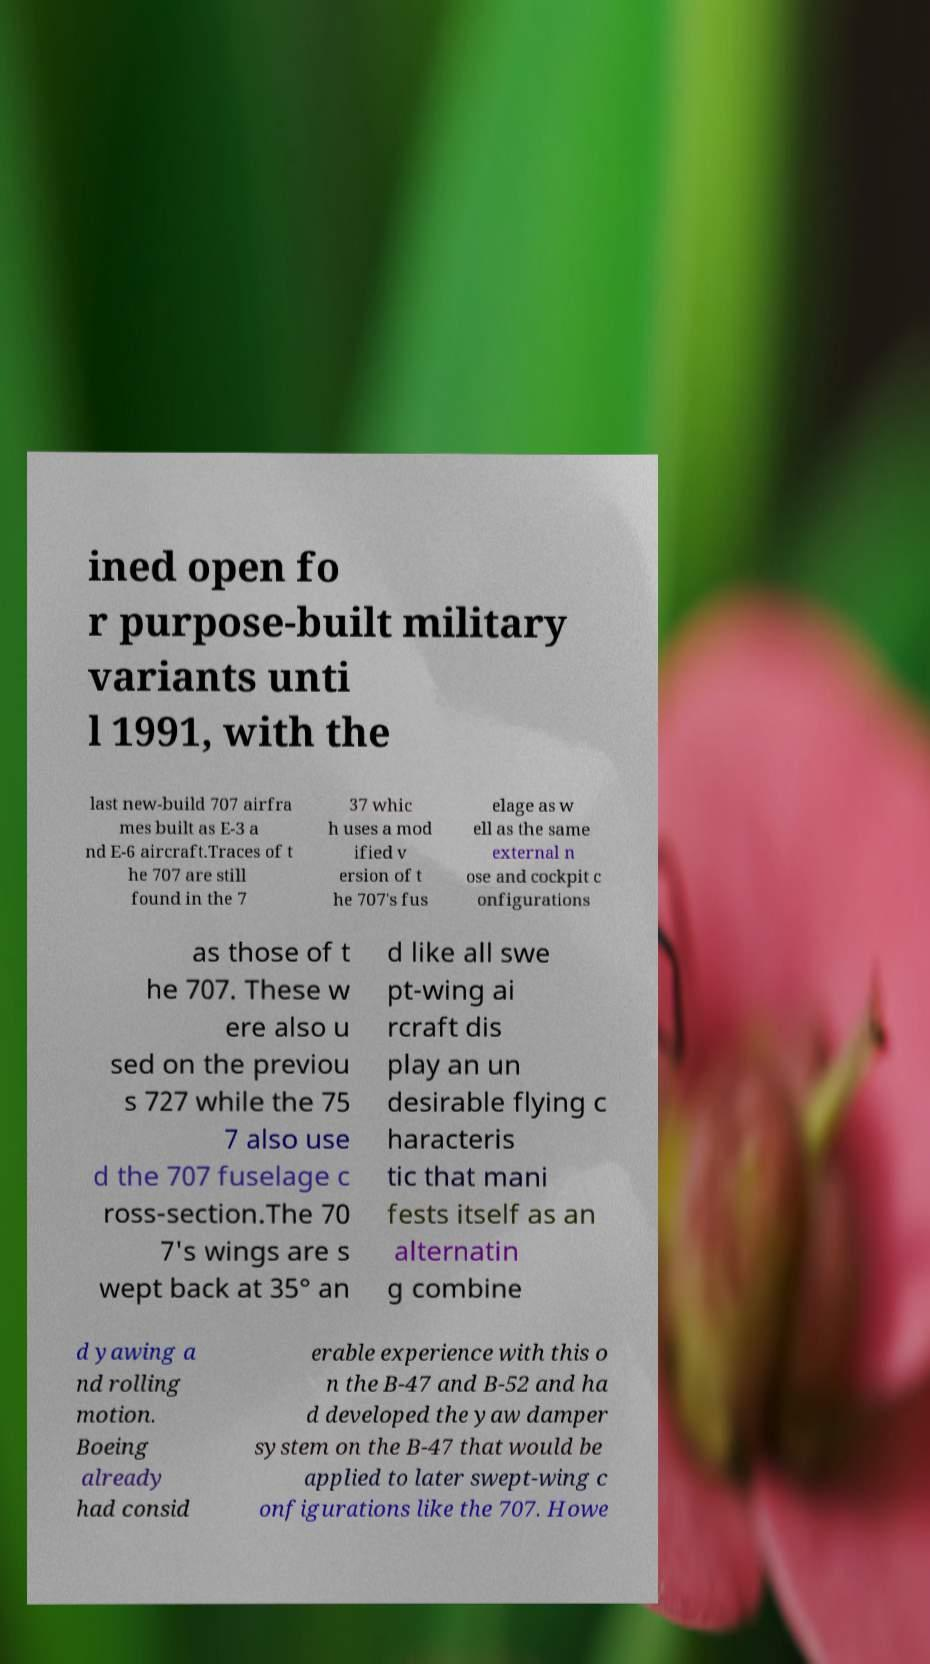Please read and relay the text visible in this image. What does it say? ined open fo r purpose-built military variants unti l 1991, with the last new-build 707 airfra mes built as E-3 a nd E-6 aircraft.Traces of t he 707 are still found in the 7 37 whic h uses a mod ified v ersion of t he 707's fus elage as w ell as the same external n ose and cockpit c onfigurations as those of t he 707. These w ere also u sed on the previou s 727 while the 75 7 also use d the 707 fuselage c ross-section.The 70 7's wings are s wept back at 35° an d like all swe pt-wing ai rcraft dis play an un desirable flying c haracteris tic that mani fests itself as an alternatin g combine d yawing a nd rolling motion. Boeing already had consid erable experience with this o n the B-47 and B-52 and ha d developed the yaw damper system on the B-47 that would be applied to later swept-wing c onfigurations like the 707. Howe 